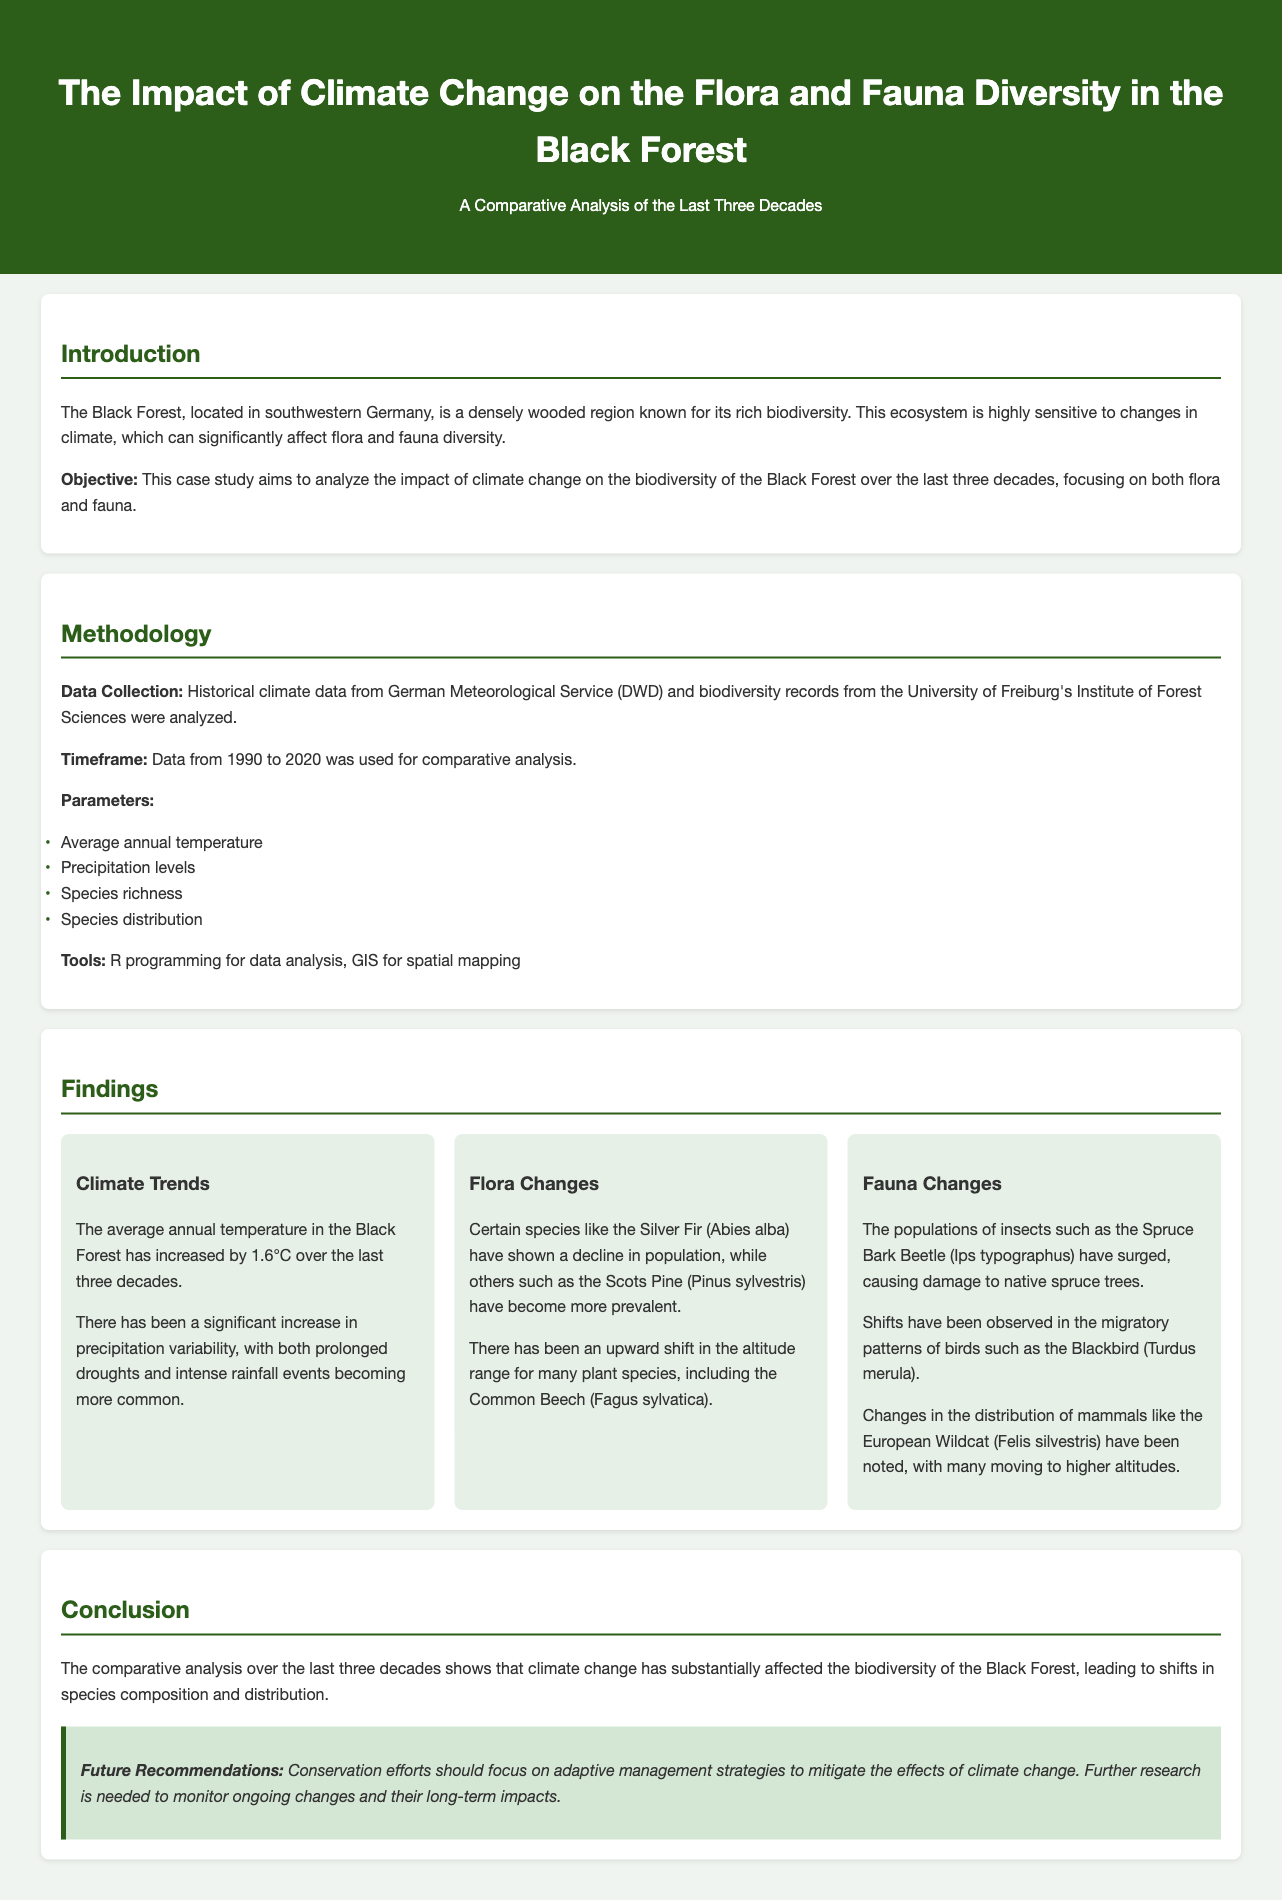What is the average annual temperature increase in the Black Forest? The average annual temperature has increased by 1.6°C over the last three decades.
Answer: 1.6°C Which species has shown a decline in population? The Silver Fir (Abies alba) has shown a decline in population.
Answer: Silver Fir (Abies alba) What year range was used for the comparative analysis? The analysis used data from 1990 to 2020.
Answer: 1990 to 2020 What phenomenon has increased variability in precipitation? The document mentions prolonged droughts and intense rainfall events becoming more common.
Answer: Increased precipitation variability What animal's population has surged according to the findings? The Spruce Bark Beetle (Ips typographus) population has surged.
Answer: Spruce Bark Beetle (Ips typographus) What adaptive strategies does the conclusion recommend? The conclusion recommends adaptive management strategies to mitigate climate change effects.
Answer: Adaptive management strategies Which species has shown an upward shift in altitude range? The Common Beech (Fagus sylvatica) has shown an upward shift in altitude range.
Answer: Common Beech (Fagus sylvatica) What organization provided biodiversity records for the study? The University of Freiburg's Institute of Forest Sciences provided biodiversity records.
Answer: University of Freiburg's Institute of Forest Sciences What was used for spatial mapping in the methodology? GIS was used for spatial mapping.
Answer: GIS 